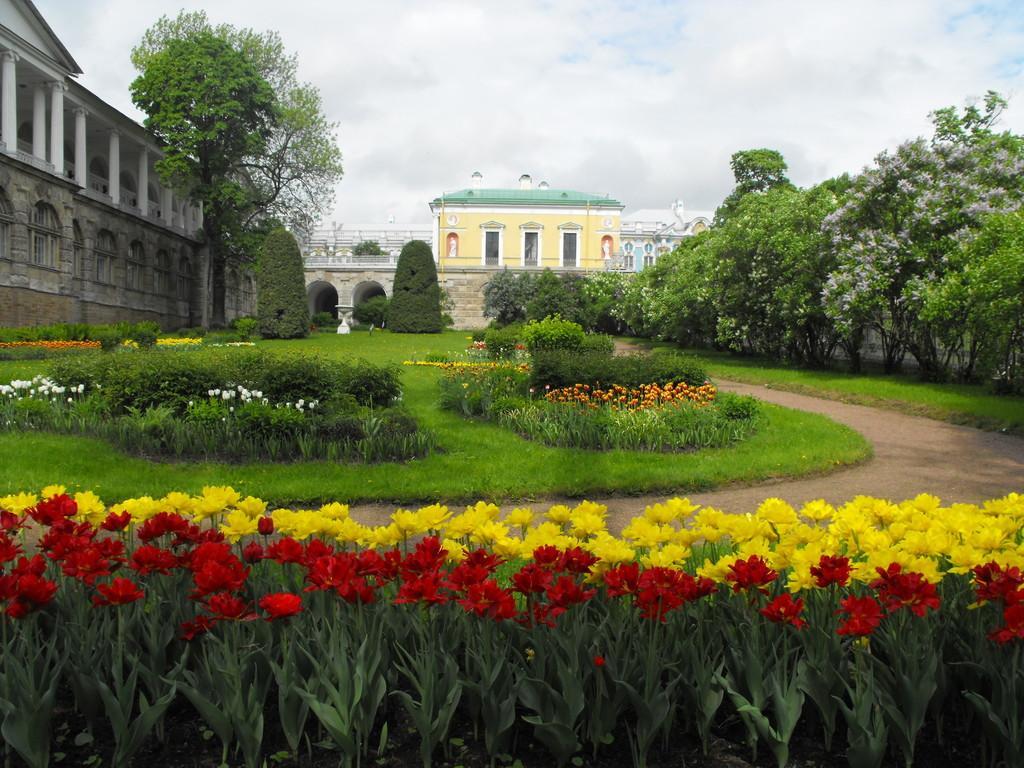Can you describe this image briefly? This picture is clicked outside the city. At the bottom of the picture, we see plants which have flowers and these flowers are in yellow and red color. Beside that, we see a road. Beside that, we see grass and plants which have flowers in white and orange color. On the right side, there are trees. In the background, we see a building in yellow and green color. We even see a railing and trees. On the left side, we see a building. At the top of the picture, we see the sky. 